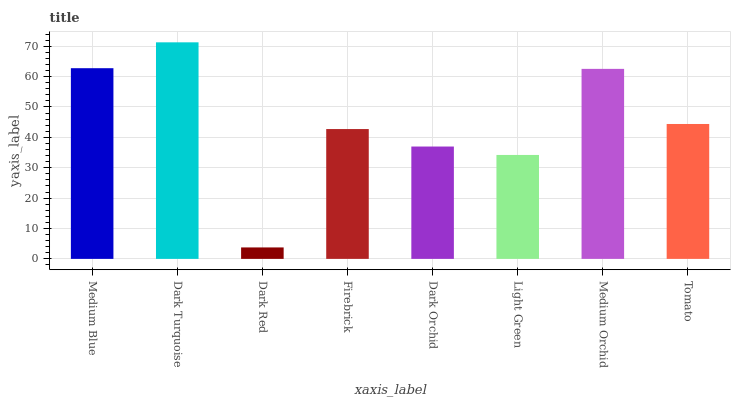Is Dark Turquoise the minimum?
Answer yes or no. No. Is Dark Red the maximum?
Answer yes or no. No. Is Dark Turquoise greater than Dark Red?
Answer yes or no. Yes. Is Dark Red less than Dark Turquoise?
Answer yes or no. Yes. Is Dark Red greater than Dark Turquoise?
Answer yes or no. No. Is Dark Turquoise less than Dark Red?
Answer yes or no. No. Is Tomato the high median?
Answer yes or no. Yes. Is Firebrick the low median?
Answer yes or no. Yes. Is Firebrick the high median?
Answer yes or no. No. Is Dark Turquoise the low median?
Answer yes or no. No. 